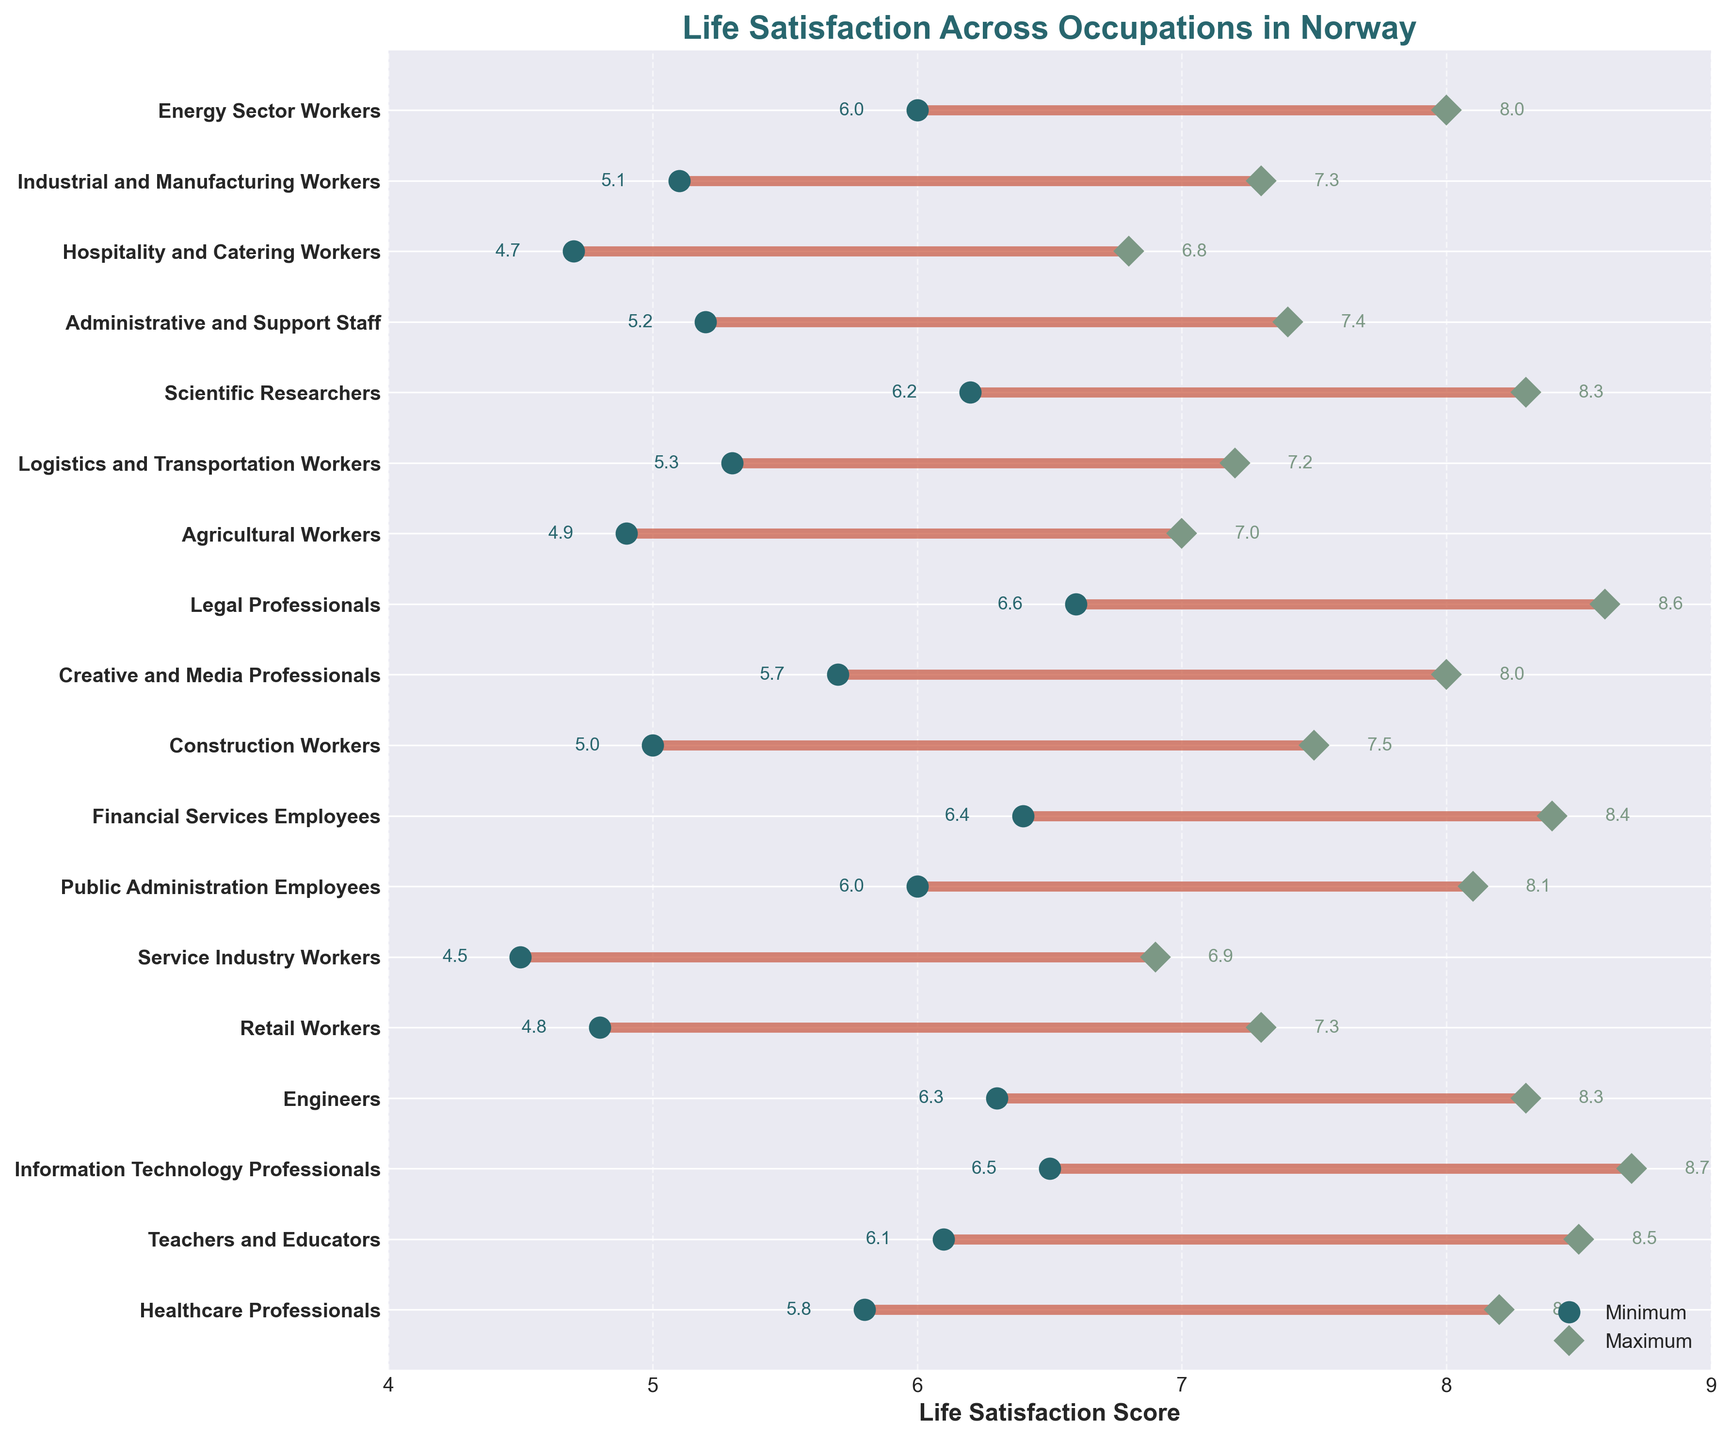What is the title of the plot? The title is the heading text that appears above the data visualization and indicates the content of the plot.
Answer: Life Satisfaction Across Occupations in Norway Which occupational group has the highest maximum satisfaction? By looking at the dots corresponding to maximum satisfaction values, locate the highest point on the horizontal axis.
Answer: Information Technology Professionals What is the range of life satisfaction scores for Retail Workers? Find the minimum and maximum satisfaction scores for Retail Workers, then calculate the difference between these two values. The range is from 4.8 to 7.3, so the calculation is 7.3 - 4.8.
Answer: 2.5 Which occupational group has the smallest range of life satisfaction scores? Find the occupational group with the smallest difference between its maximum and minimum satisfaction scores by inspecting the lengths of the lines connecting minimum and maximum dots.
Answer: Public Administration Employees What is the average life satisfaction score for Engineers? Calculate the average by adding the minimum and maximum scores for Engineers, then divide by 2. The scores are 6.3 and 8.3, so the sum is 6.3 + 8.3 = 14.6. The average is 14.6 / 2.
Answer: 7.3 Which occupational group has the lowest minimum satisfaction score? By examining the positions of the minimum satisfaction dots, identify the lowest point on the horizontal axis.
Answer: Service Industry Workers How many occupational groups have a minimum satisfaction score greater than 6? Count the number of occupational groups where the minimum satisfaction score dot is positioned beyond the 6.0 mark on the horizontal axis.
Answer: 7 What is the difference in maximum satisfaction scores between Legal Professionals and Creative and Media Professionals? Subtract the maximum score of Creative and Media Professionals from that of Legal Professionals. The scores are 8.6 (Legal) and 8.0 (Creative), so the difference is 8.6 - 8.0.
Answer: 0.6 What is the average maximum satisfaction score of all occupational groups? Sum the maximum scores of all occupational groups and divide by the number of groups. The scores are (8.2 + 8.5 + 8.7 + 8.3 + 7.3 + 6.9 + 8.1 + 8.4 + 7.5 + 8.0 + 8.6 + 7.0 + 7.2 + 8.3 + 7.4 + 6.8 + 7.3 + 8.0), the total count is 18.
Answer: 7.8 